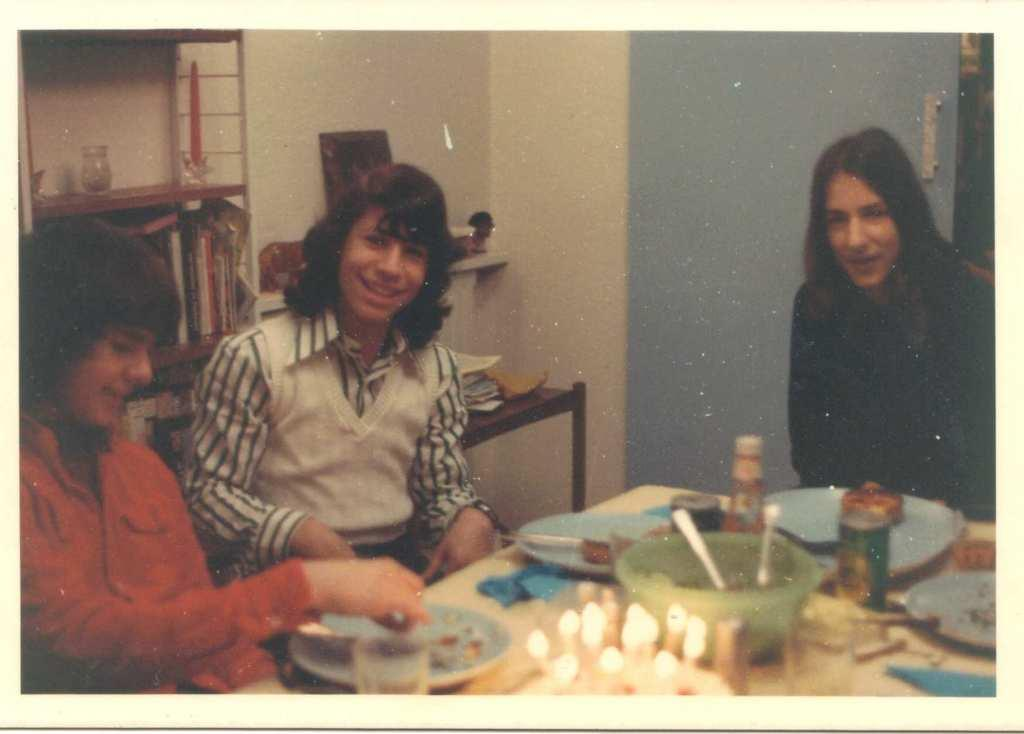How many girls are in the image? There are multiple girls in the image. What are the girls doing in the image? The girls are sitting around a table. What is on the table in the image? There is food served in bowls on the table. What else can be seen in the image besides the girls and the table? There is a shelf with books visible in the image. What type of pain can be seen on the girls' faces in the image? There is no indication of pain on the girls' faces in the image; they appear to be engaged in a normal activity. 